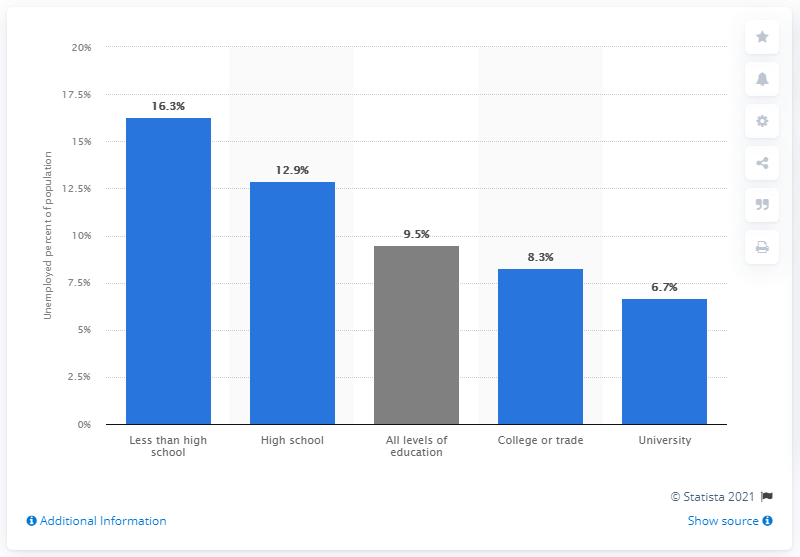Mention a couple of crucial points in this snapshot. In 2020, the unemployment rate in Canada was 9.5%. 